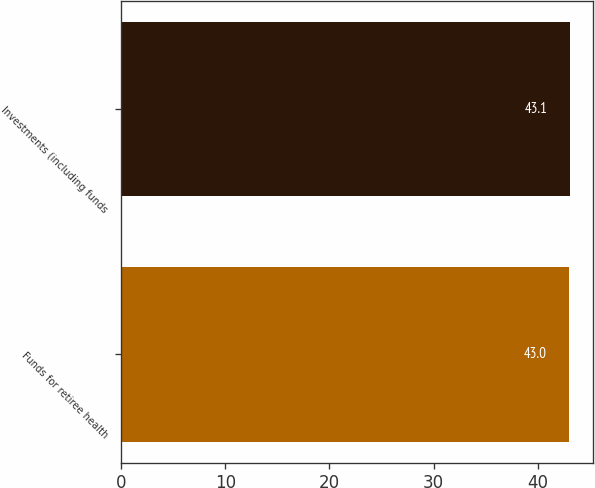<chart> <loc_0><loc_0><loc_500><loc_500><bar_chart><fcel>Funds for retiree health<fcel>Investments (including funds<nl><fcel>43<fcel>43.1<nl></chart> 